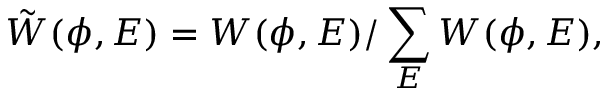<formula> <loc_0><loc_0><loc_500><loc_500>\tilde { W } ( \phi , E ) = W ( \phi , E ) / \sum _ { E } W ( \phi , E ) ,</formula> 